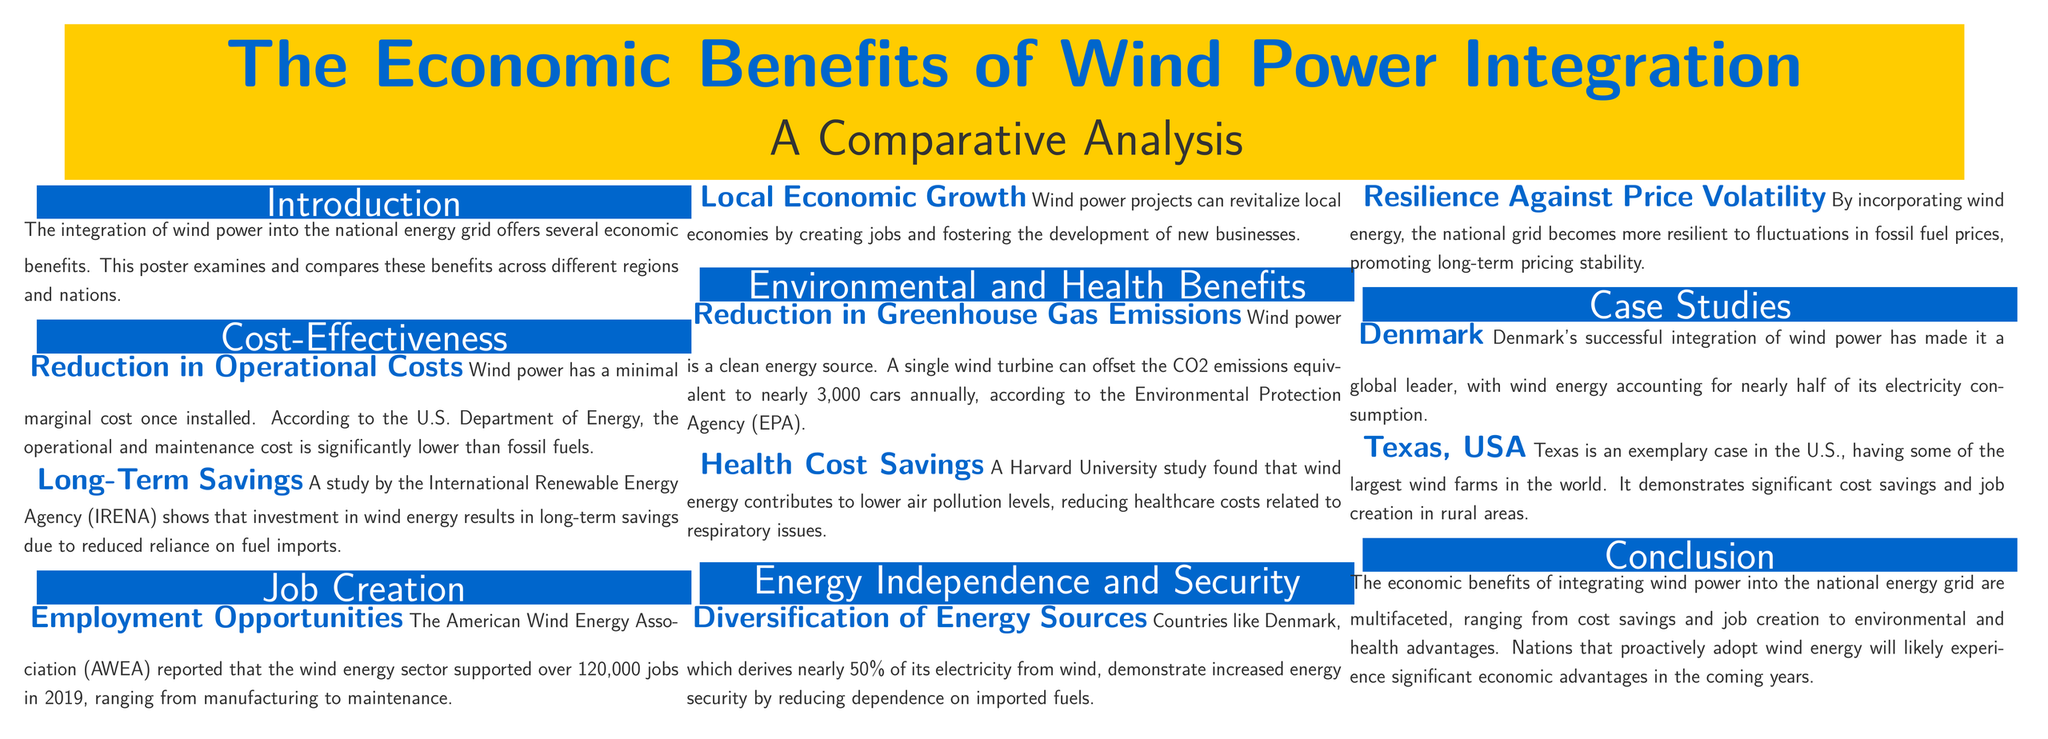what is the main topic of the poster? The poster focuses on economic benefits associated with wind power integration into the national energy grid.
Answer: The Economic Benefits of Wind Power Integration how many jobs did the wind energy sector support in 2019? The American Wind Energy Association reported that 120,000 jobs were supported in the wind energy sector in 2019.
Answer: 120,000 what percentage of electricity does Denmark derive from wind? The poster states that Denmark derives nearly 50% of its electricity from wind energy.
Answer: 50% what are two benefits of wind power mentioned in the environmental and health section? The benefits mentioned include reducing greenhouse gas emissions and healthcare cost savings related to lower air pollution levels.
Answer: Reduction in Greenhouse Gas Emissions, Health Cost Savings which organization reported lower operational costs for wind power? The U.S. Department of Energy is the organization that reported the lower operational and maintenance costs for wind power compared to fossil fuels.
Answer: U.S. Department of Energy in which U.S. state are some of the largest wind farms located? Texas is highlighted as having some of the largest wind farms in the world.
Answer: Texas what is one effect of wind power on local economies? Wind power projects can revitalize local economies by creating jobs and fostering the development of new businesses.
Answer: Local Economic Growth what organization conducted a study related to health cost savings from wind energy? The Harvard University conducted the study that found wind energy contributes to lower air pollution levels.
Answer: Harvard University 